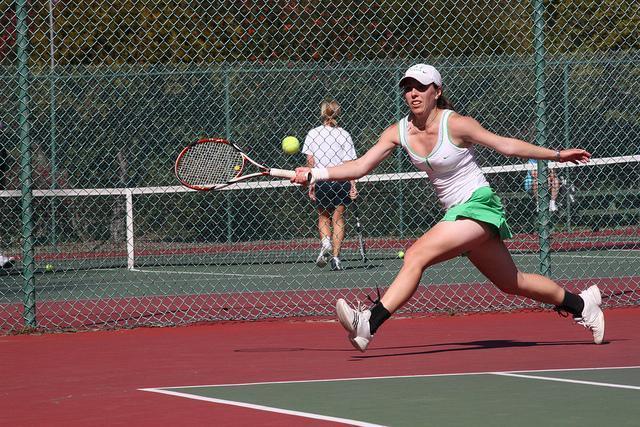How many tennis rackets are in the picture?
Give a very brief answer. 1. How many people are visible?
Give a very brief answer. 2. 